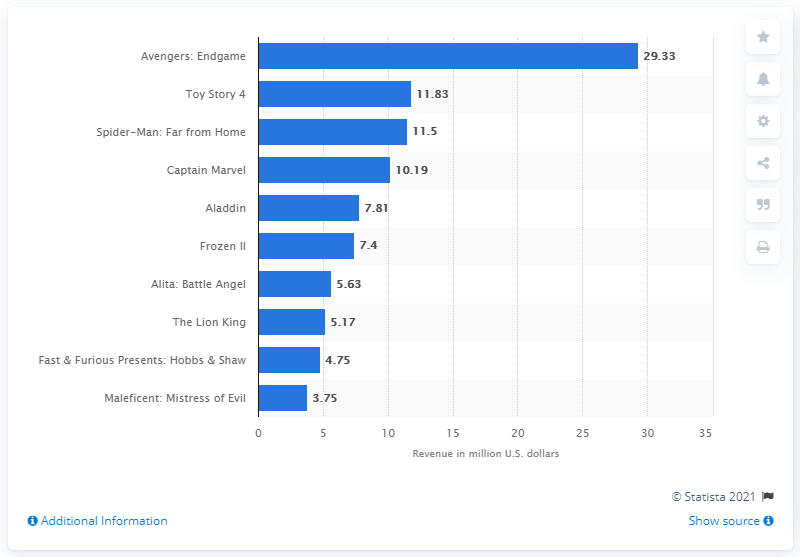Mention a couple of crucial points in this snapshot. In 2019, the movie "Avengers: Endgame" earned a total of $29.33 million in U.S. dollars in Hong Kong. 